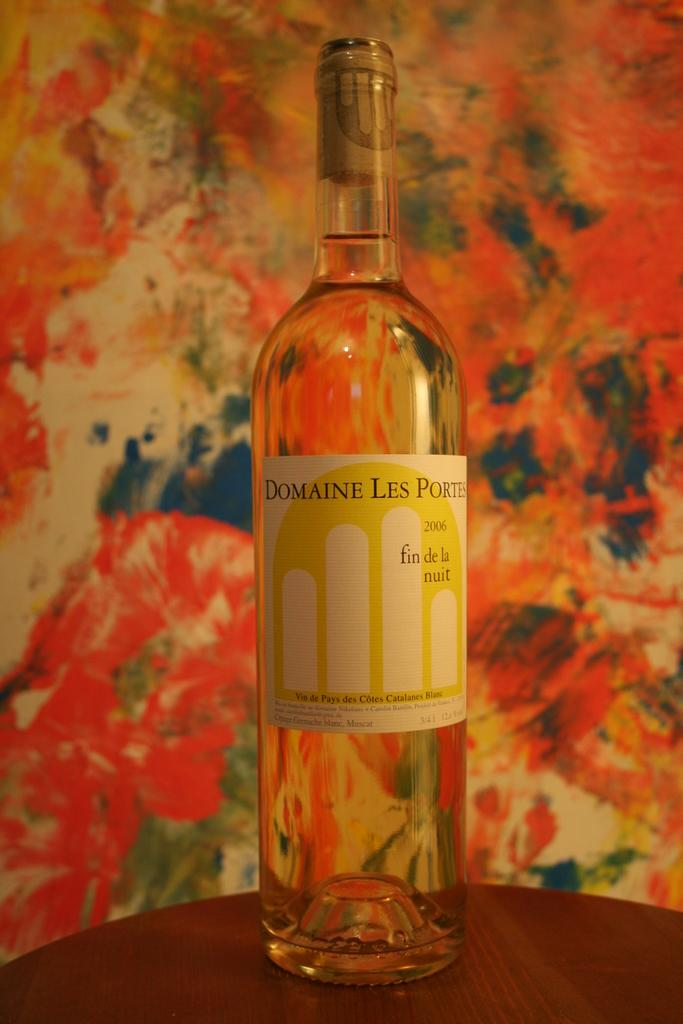<image>
Present a compact description of the photo's key features. A bottle of Domaine Les Portes wine sits on a small table against a paint splattered wall. 